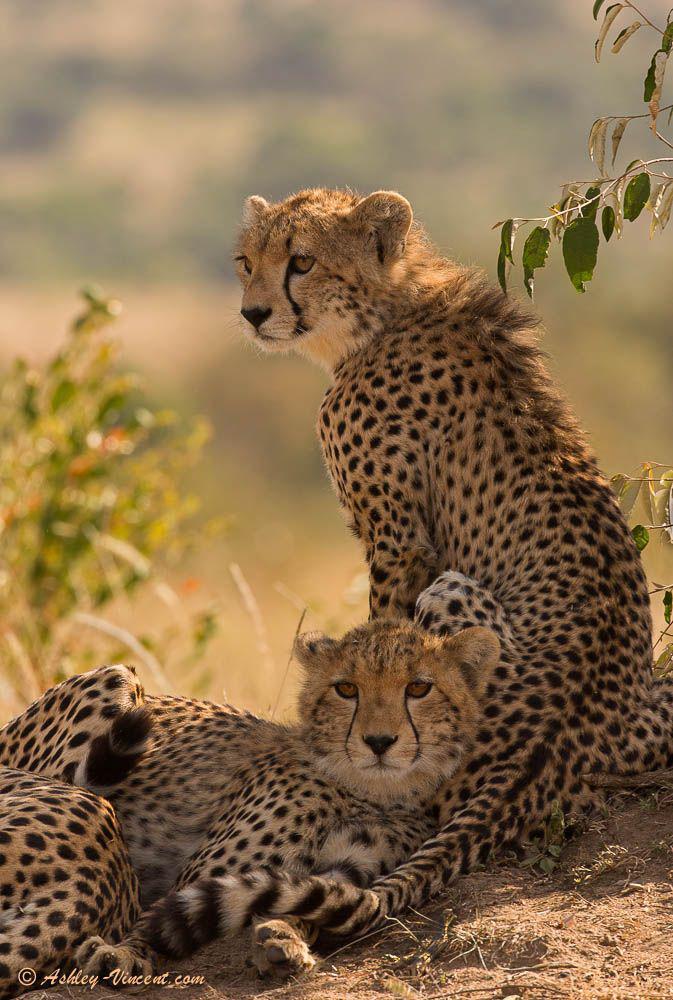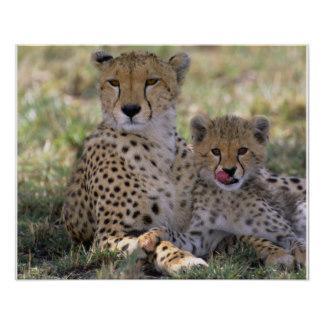The first image is the image on the left, the second image is the image on the right. For the images shown, is this caption "There is exactly two cheetahs in the left image." true? Answer yes or no. Yes. 